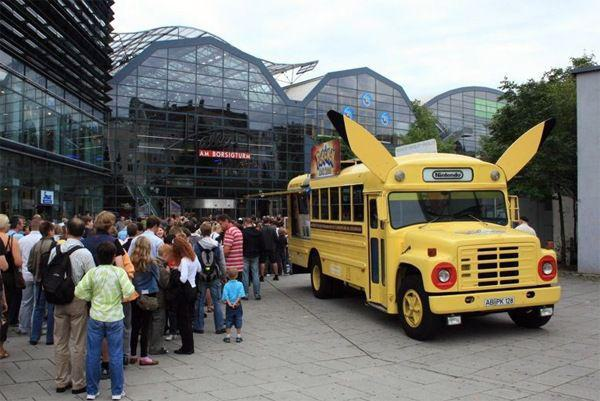What kind of event do you think is associated with the vehicle? Given the playful design of the vehicle as Pikachu and the crowd nearby, it's plausible that this could be part of a promotional event for Pokémon, perhaps a game release or a fan convention. Such a vehicle could also be used to transport attendees at such events or to serve as a unique photo opportunity that promotes engagement with the brand.  How might people react to seeing this vehicle? People, especially Pokémon fans, are likely to react with delight and excitement upon seeing this vehicle. It's a visually engaging and nostalgic design that could spark conversations, photo sharing on social media, and general enthusiasm for participating in whatever event it's associated with. 